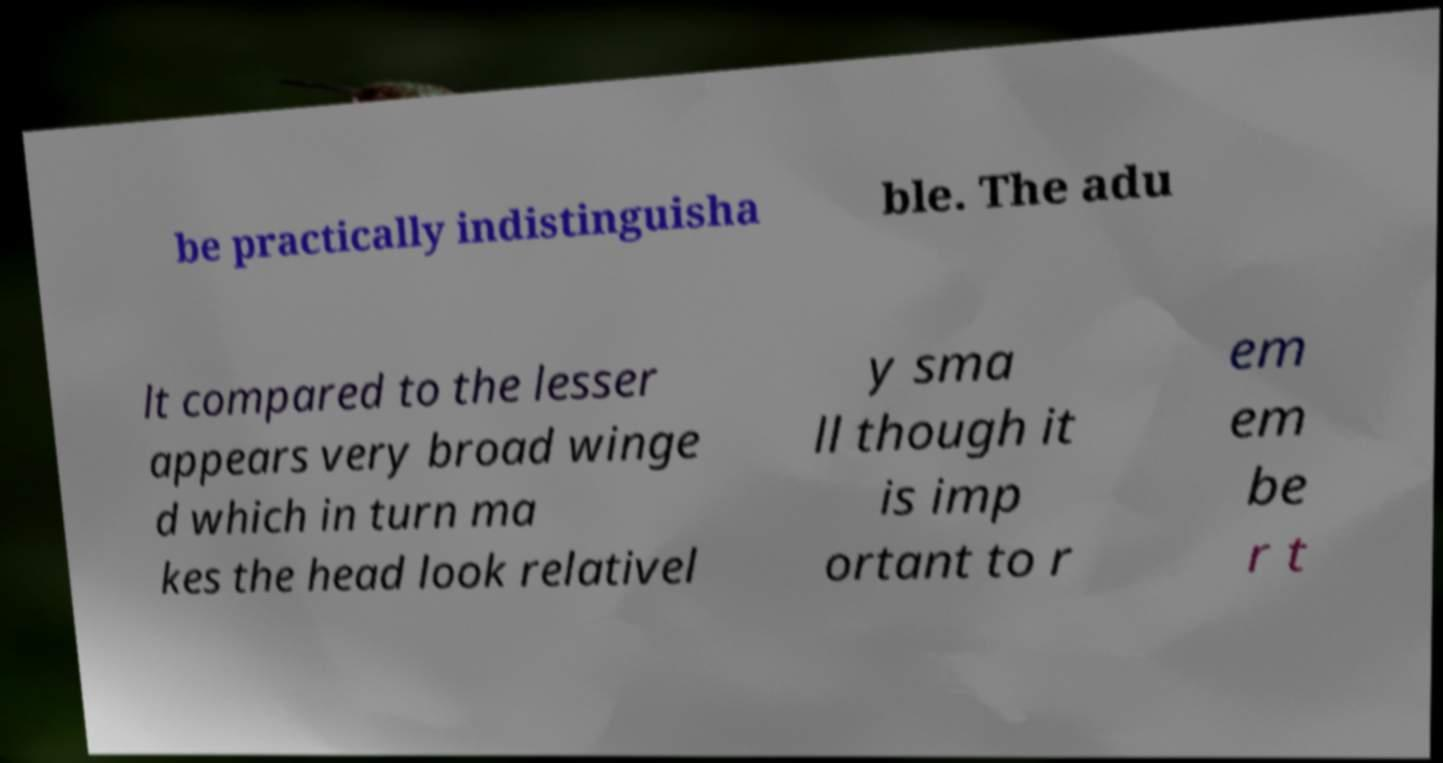Please read and relay the text visible in this image. What does it say? be practically indistinguisha ble. The adu lt compared to the lesser appears very broad winge d which in turn ma kes the head look relativel y sma ll though it is imp ortant to r em em be r t 